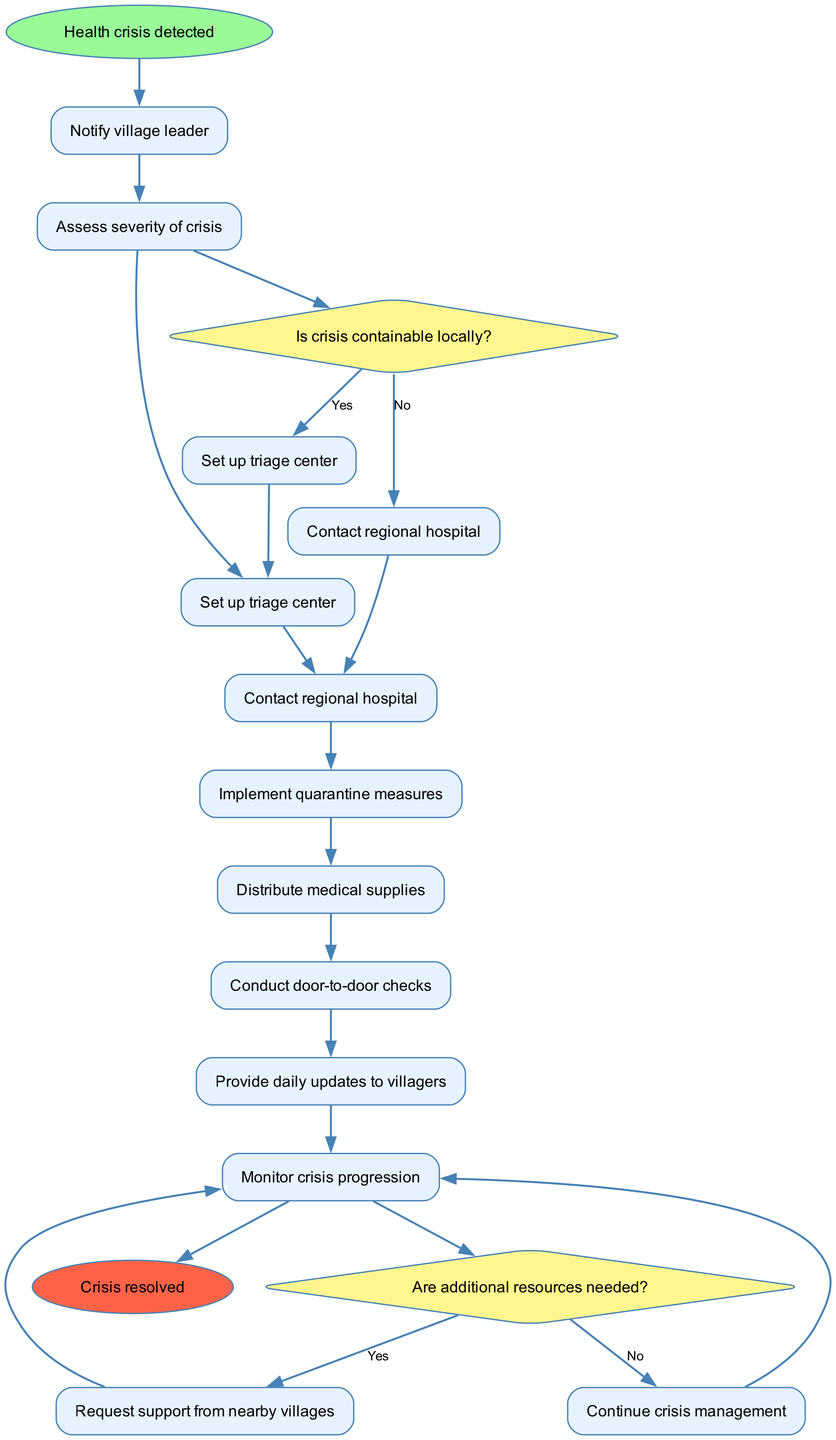What is the first action in the emergency response procedure? The first action mentioned in the diagram is "Notify village leader." It is the starting point of the flowchart, indicating the initial response to the health crisis.
Answer: Notify village leader How many main procedure nodes are there? Counting the nodes listed under "nodes," there are eight main procedure nodes that describe subsequent steps after the health crisis is detected.
Answer: Eight What happens if the crisis is not containable locally? If the crisis is determined to be not containable locally, the procedure flows to "Contact regional hospital." This decision stems from the first decision point regarding the local containment capability.
Answer: Contact regional hospital What is done after assessing the severity of the crisis? After assessing the severity of the crisis, the next step according to the flowchart is to "Set up triage center." This indicates that the assessment influences the immediate operational steps.
Answer: Set up triage center What action is taken if additional resources are needed? If additional resources are deemed necessary, the flow continues to "Request support from nearby villages." This is the resulting action when the condition of needing more resources is affirmed.
Answer: Request support from nearby villages How many decisions are made in the flowchart? There are two decision points present in the flowchart, each leading to different paths based on the current situation assessment regarding crisis containment and resource needs.
Answer: Two What connects the node "Conduct door-to-door checks"? The node "Conduct door-to-door checks" is connected from the previous node "Distribute medical supplies," indicating that this action follows the distribution stage. This implies a sequence of operations starting from prior measures.
Answer: Distribute medical supplies Where does the procedure lead after "Monitor crisis progression"? After "Monitor crisis progression," the flowchart logically concludes with the "Crisis resolved" node, indicating a successful resolution following the monitoring phase.
Answer: Crisis resolved 